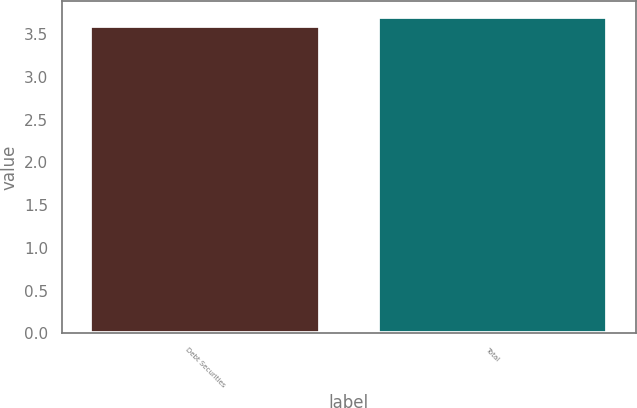<chart> <loc_0><loc_0><loc_500><loc_500><bar_chart><fcel>Debt Securities<fcel>Total<nl><fcel>3.6<fcel>3.7<nl></chart> 